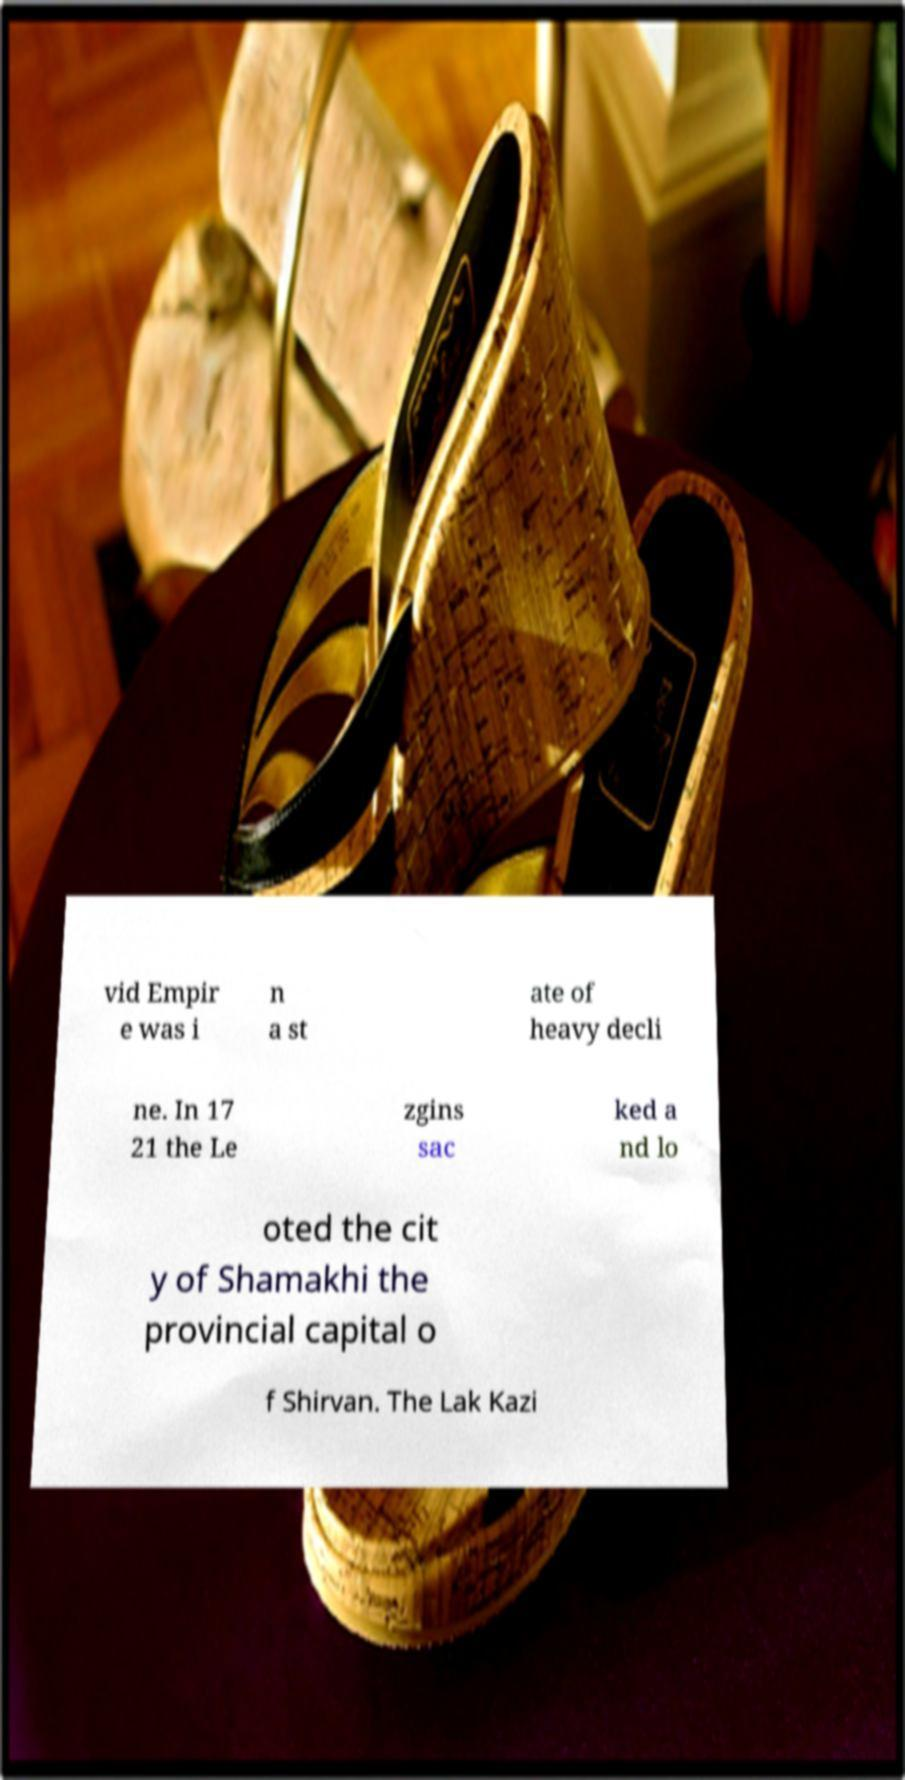Could you extract and type out the text from this image? vid Empir e was i n a st ate of heavy decli ne. In 17 21 the Le zgins sac ked a nd lo oted the cit y of Shamakhi the provincial capital o f Shirvan. The Lak Kazi 